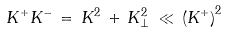<formula> <loc_0><loc_0><loc_500><loc_500>K ^ { + } K ^ { - } \, = \, K ^ { 2 } \, + \, K _ { \perp } ^ { 2 } \, \ll \, \left ( K ^ { + } \right ) ^ { 2 }</formula> 